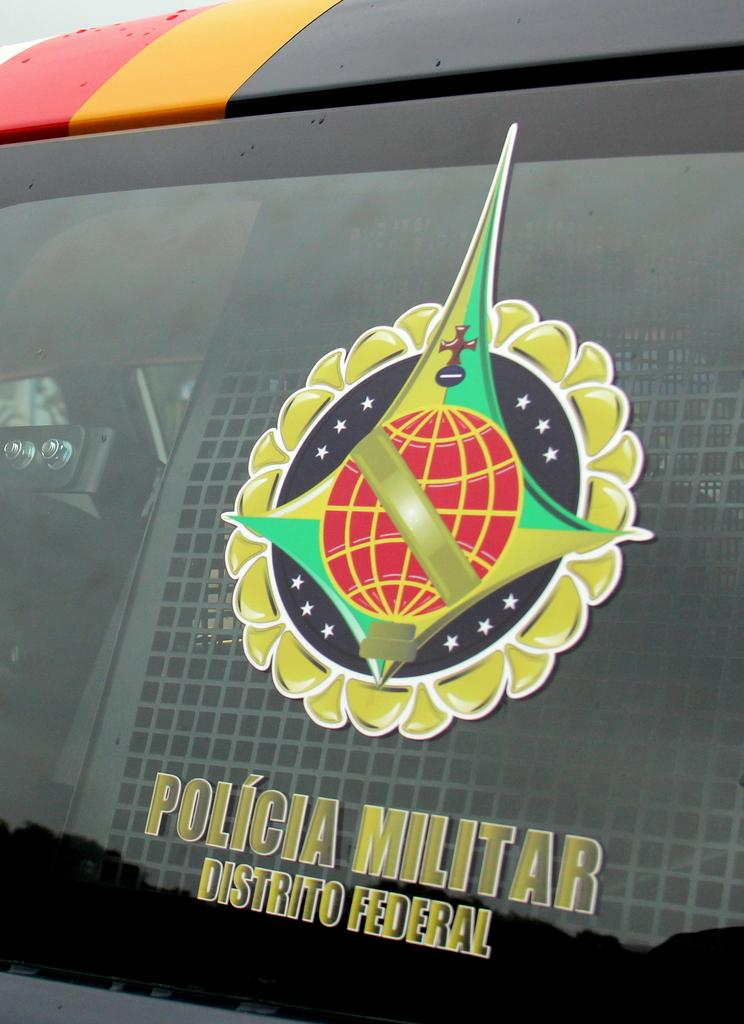<image>
Give a short and clear explanation of the subsequent image. A logo and a sign for Policia Militar Distrito Federal 